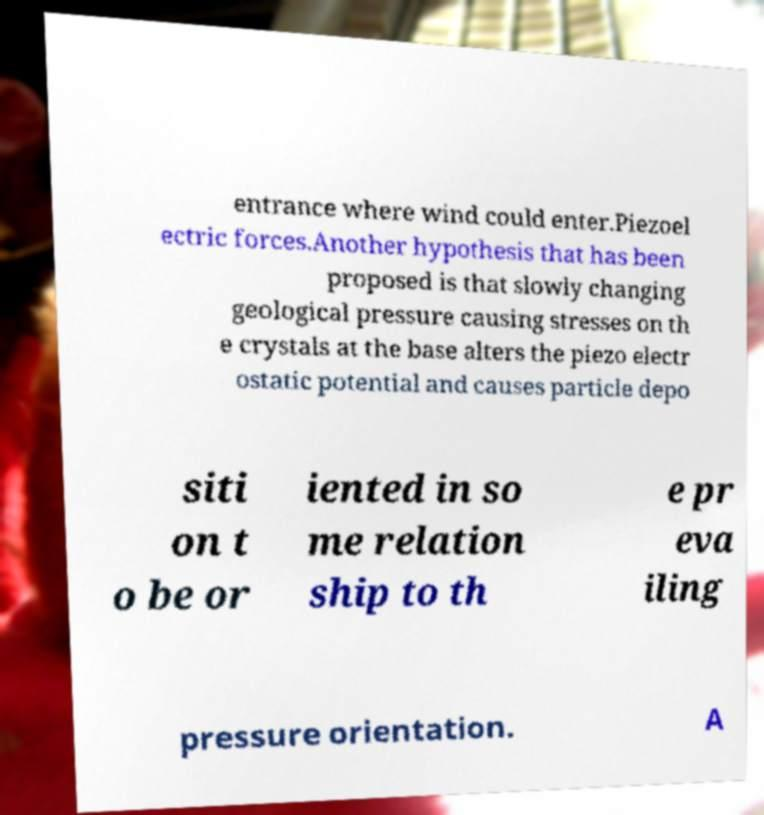Could you extract and type out the text from this image? entrance where wind could enter.Piezoel ectric forces.Another hypothesis that has been proposed is that slowly changing geological pressure causing stresses on th e crystals at the base alters the piezo electr ostatic potential and causes particle depo siti on t o be or iented in so me relation ship to th e pr eva iling pressure orientation. A 